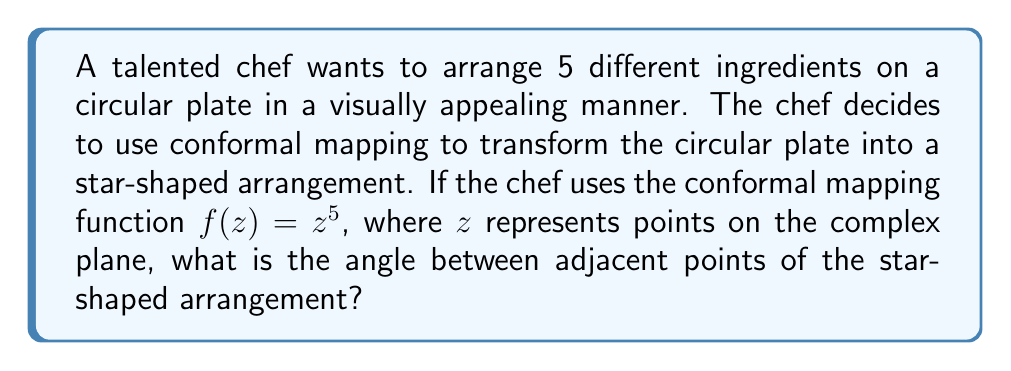Can you solve this math problem? To solve this problem, we'll follow these steps:

1) The conformal mapping function $f(z) = z^5$ maps points from the complex z-plane to the w-plane.

2) In the z-plane, points on the unit circle can be represented as $z = e^{i\theta}$, where $\theta$ is the angle from the positive real axis.

3) Applying the mapping function:
   
   $w = f(z) = (e^{i\theta})^5 = e^{5i\theta}$

4) This means that as $\theta$ goes from 0 to $2\pi$ in the z-plane, the angle in the w-plane, $5\theta$, goes from 0 to $10\pi$.

5) The result is a 5-pointed star shape in the w-plane, as the angle wraps around 5 times.

6) To find the angle between adjacent points of the star, we need to determine how much $\theta$ needs to change in the z-plane to make a complete revolution in the w-plane.

7) A complete revolution is $2\pi$ radians. So we solve:

   $5\theta = 2\pi$
   $\theta = \frac{2\pi}{5}$

8) This means that every $\frac{2\pi}{5}$ radians in the z-plane corresponds to a full $2\pi$ rotation in the w-plane.

9) The angle between adjacent points of the star in the w-plane is therefore:

   $2\pi - \frac{2\pi}{5} = \frac{8\pi}{5}$ radians

10) Converting to degrees:

    $\frac{8\pi}{5} \cdot \frac{180^{\circ}}{\pi} = 288^{\circ}$
Answer: The angle between adjacent points of the star-shaped arrangement is $\frac{8\pi}{5}$ radians or $288^{\circ}$. 